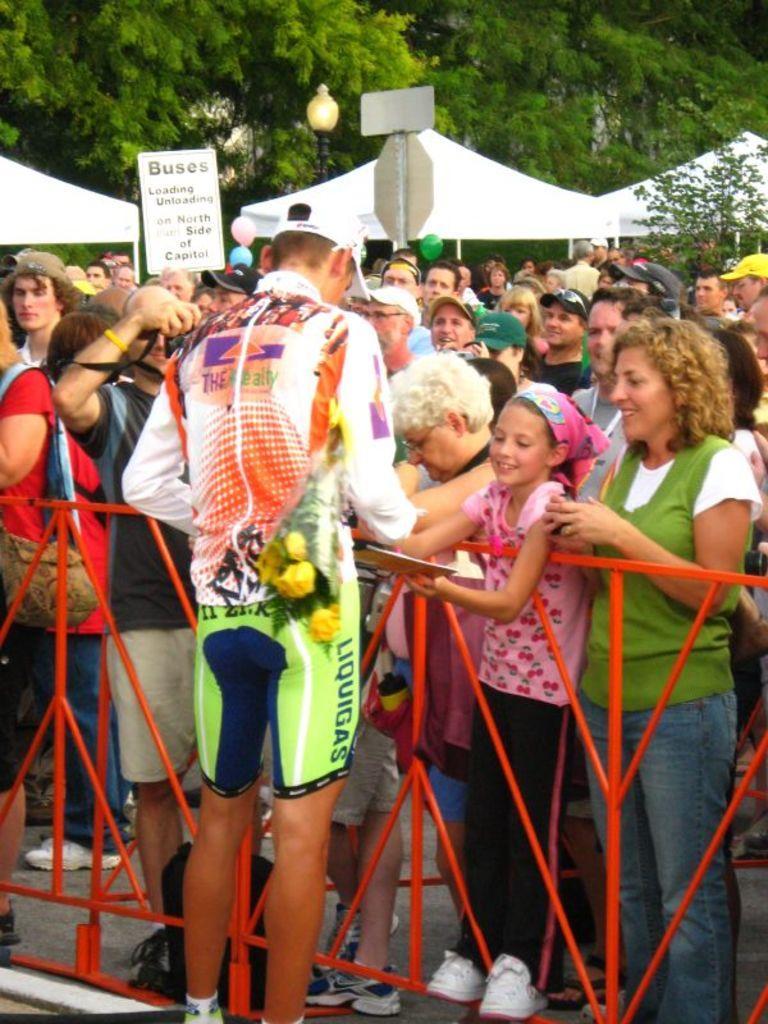Describe this image in one or two sentences. In this picture I can see few tents and few people are standing and I can see a man holding a placard with some text on it and another human holding a camera and taking picture and I can see few of them wore caps on their heads and I can see trees and a man standing and writing on the paper holding a flower bouquet and I can see a metal fence. 